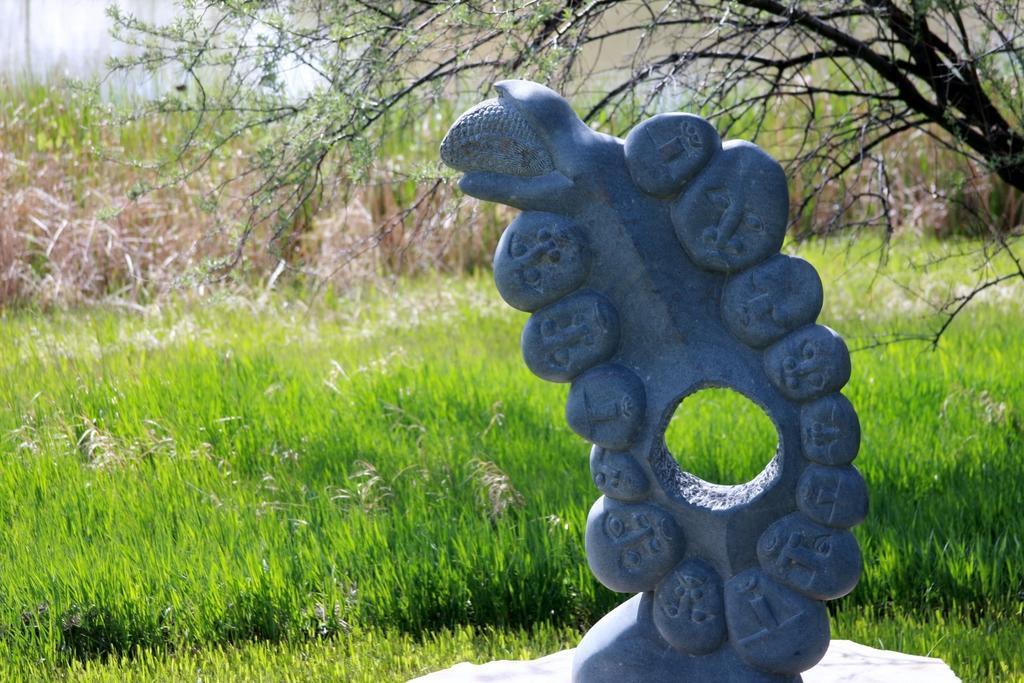Can you describe this image briefly? In the picture we can see a sculpture on the stone and besides to it, we can see a grass plant and behind it we can see some dried plants and a tree. 